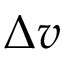<formula> <loc_0><loc_0><loc_500><loc_500>\Delta v</formula> 